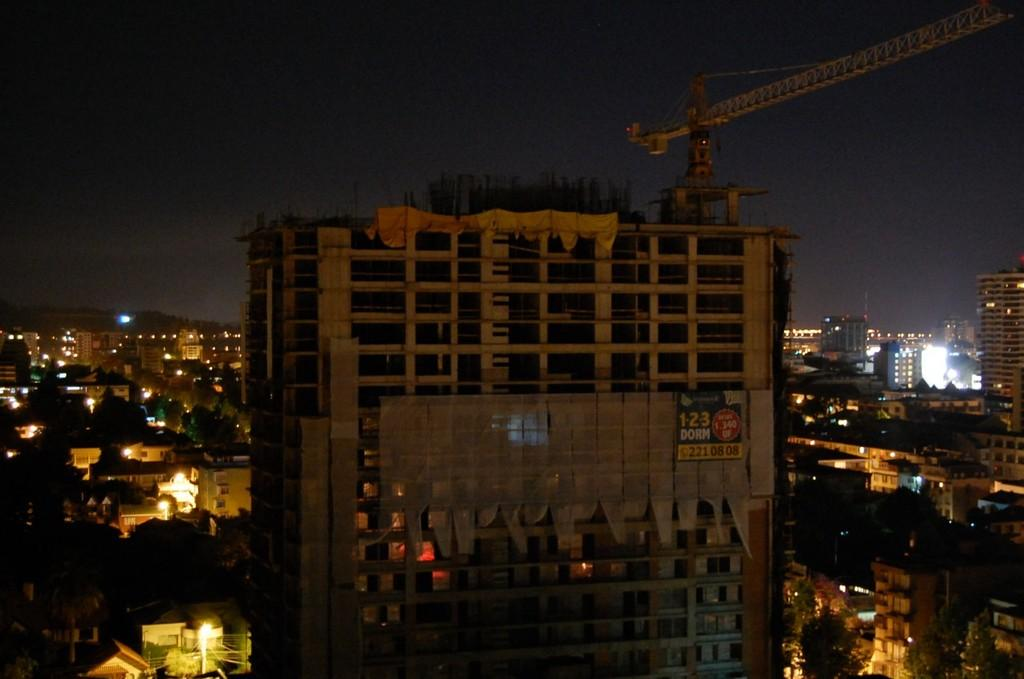What type of structure is present in the image? There is a building in the image. What is attached to the building? There is a tower crane on the building, and there is also a banner. How many buildings can be seen in the image? There are many buildings visible in the image. What else is present in the image besides buildings? There are trees, lights, and the sky is visible in the background. What type of coil can be seen in the image? There is no coil present in the image. What does the building smell like in the image? The image does not convey any information about the smell of the building. 